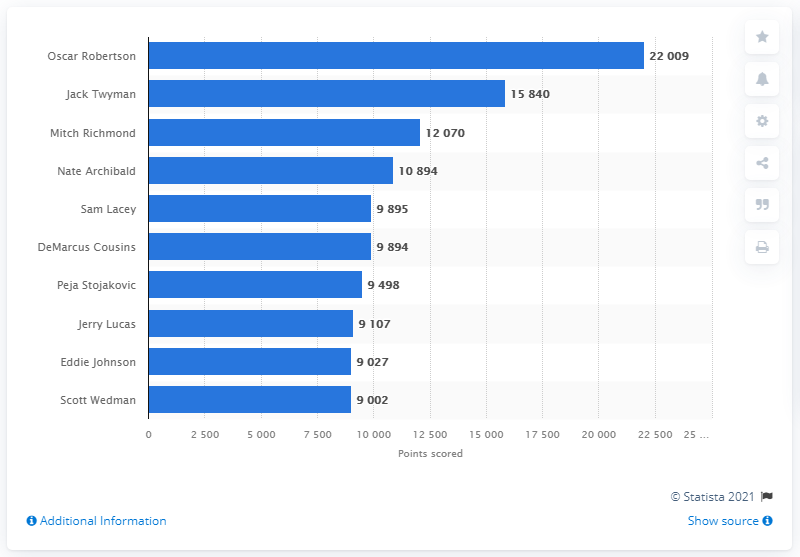Outline some significant characteristics in this image. Oscar Robertson is the career points leader of the Sacramento Kings. 